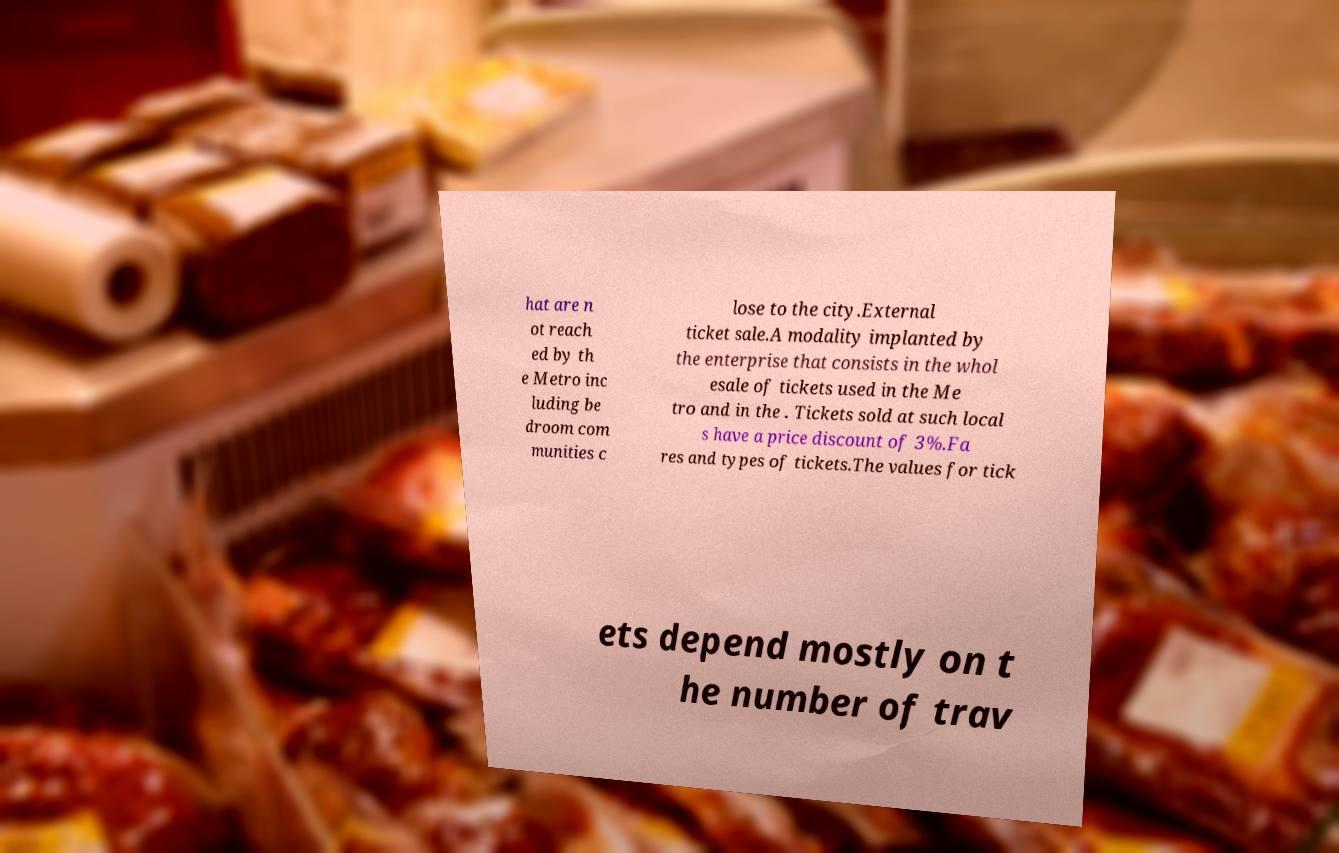Can you accurately transcribe the text from the provided image for me? hat are n ot reach ed by th e Metro inc luding be droom com munities c lose to the city.External ticket sale.A modality implanted by the enterprise that consists in the whol esale of tickets used in the Me tro and in the . Tickets sold at such local s have a price discount of 3%.Fa res and types of tickets.The values for tick ets depend mostly on t he number of trav 